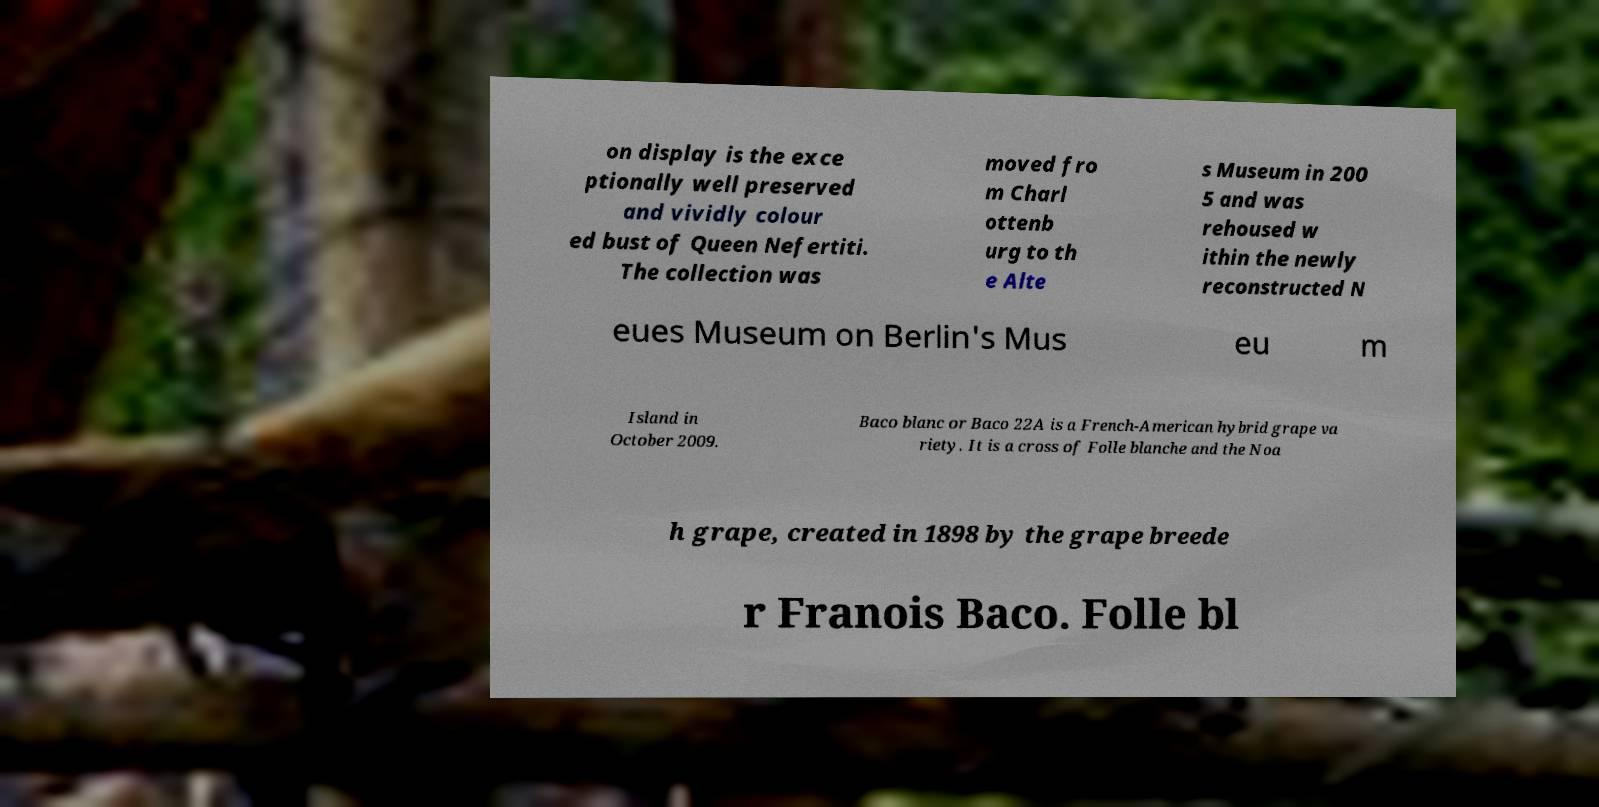For documentation purposes, I need the text within this image transcribed. Could you provide that? on display is the exce ptionally well preserved and vividly colour ed bust of Queen Nefertiti. The collection was moved fro m Charl ottenb urg to th e Alte s Museum in 200 5 and was rehoused w ithin the newly reconstructed N eues Museum on Berlin's Mus eu m Island in October 2009. Baco blanc or Baco 22A is a French-American hybrid grape va riety. It is a cross of Folle blanche and the Noa h grape, created in 1898 by the grape breede r Franois Baco. Folle bl 